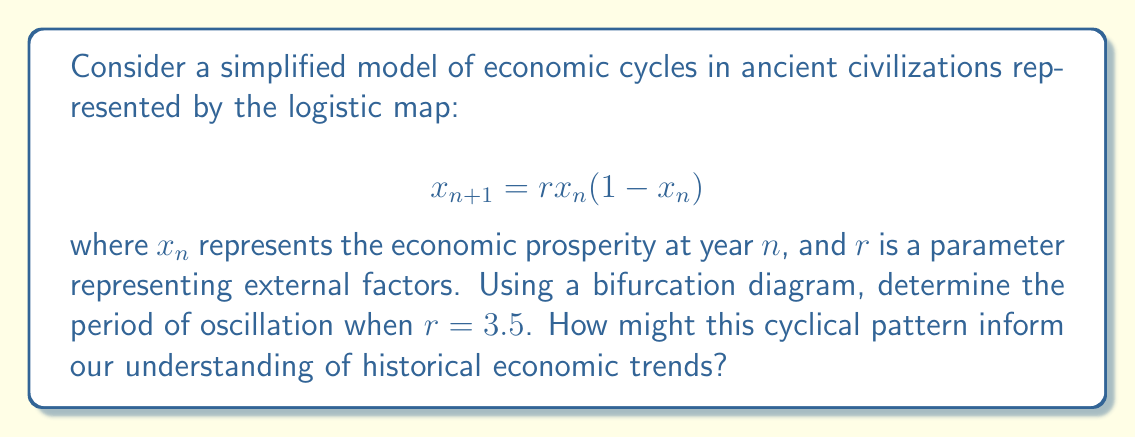Help me with this question. To determine the period of oscillation using a bifurcation diagram for the logistic map:

1. Understand the bifurcation diagram:
   - The x-axis represents the parameter $r$
   - The y-axis shows the long-term behavior of $x_n$

2. Analyze the behavior at $r = 3.5$:
   - Locate $r = 3.5$ on the bifurcation diagram
   - Observe the number of distinct y-values at this point

3. Interpret the diagram:
   - At $r = 3.5$, we see four distinct y-values
   - This indicates a period-4 cycle

4. Understand the historical implications:
   - A period-4 cycle suggests the economy repeats every 4 "years"
   - This could represent phases like growth, peak, decline, and trough

5. Consider the limitations:
   - This is a simplified model and may not capture all complexities
   - Real historical cycles are often more nuanced

6. Historical analysis:
   - Compare this pattern to known economic cycles in ancient civilizations
   - Look for evidence of approximately 4-phase patterns in historical records

This approach combines mathematical modeling with historical analysis, offering a new perspective on cyclical patterns in economic history.
Answer: Period-4 oscillation 